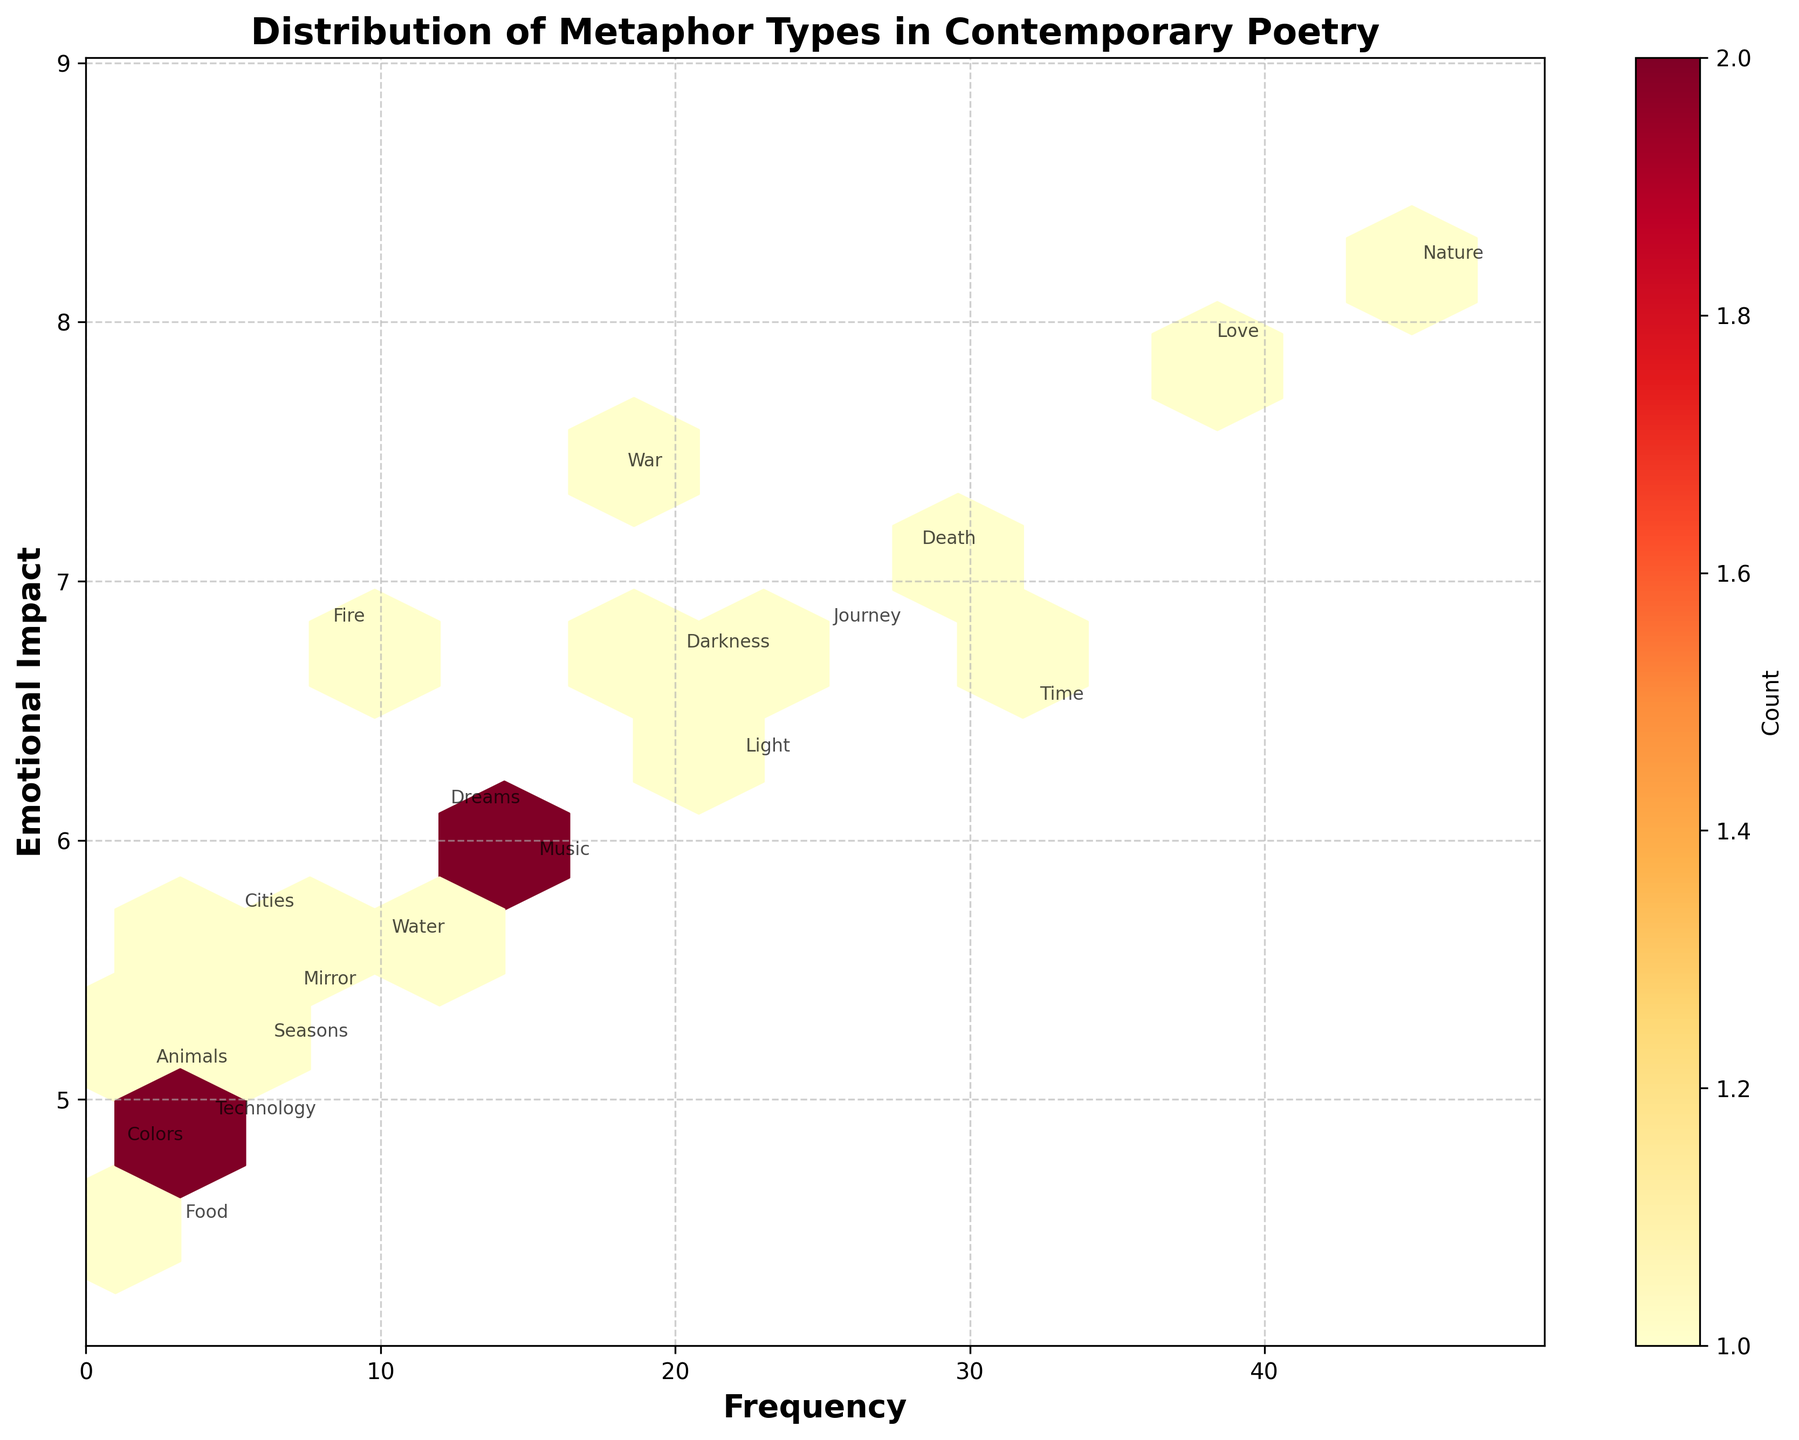What's the title of the plot? The title is typically displayed at the top of the plot and clearly indicates the main subject. By observing the figure, you can read the title.
Answer: Distribution of Metaphor Types in Contemporary Poetry What do the x and y axes represent? The labels on the x and y axes indicate what each axis represents. By reading these labels, one can understand their meanings.
Answer: The x-axis represents Frequency, and the y-axis represents Emotional Impact How many metaphor types are plotted in the figure? By annotating the figure with the metaphor types, we can visually count the number of labels that represent different metaphor types.
Answer: 19 Which metaphor has the highest frequency? By looking at the positions along the x-axis, the metaphor with the farthest right position has the highest frequency.
Answer: Nature Describe the relationship between frequency and emotional impact. By observing the general pattern of the hexbin plot, you can describe whether there is a positive, negative, or no apparent correlation.
Answer: Generally positive correlation Which metaphor type has the closest frequency to 25? By observing the x-axis, we find the metaphor type that is nearest to the value 25.
Answer: Journey Which metaphor has the lowest emotional impact? By looking at the bottom-most position on the y-axis, the metaphor type at the lowest point will have the lowest emotional impact.
Answer: Food Which metaphors have an emotional impact greater than 7? By looking at the values above 7 on the y-axis and observing which metaphor types are annotated there, we identify those metaphors.
Answer: Nature, Love, Death, War What is the combined frequency of metaphors related to light and darkness? Add the frequencies of the metaphors related to light and darkness. From the figure, find the values and sum them up. Both metaphors are annotated, so their frequencies are easily identifiable. Light: 22, Darkness: 20, therefore 22 + 20 = 42
Answer: 42 Which hexbin cell has the highest count and what might it represent? The color intensity in a hexbin plot represents the count. The most intense color indicates the highest count. Observing the hue, and then considering which data points might be aggregated there, we infer the most frequent nearby metaphor types.
Answer: Around the mid-range of frequencies and emotional impact, representing a concentration of common metaphor types 